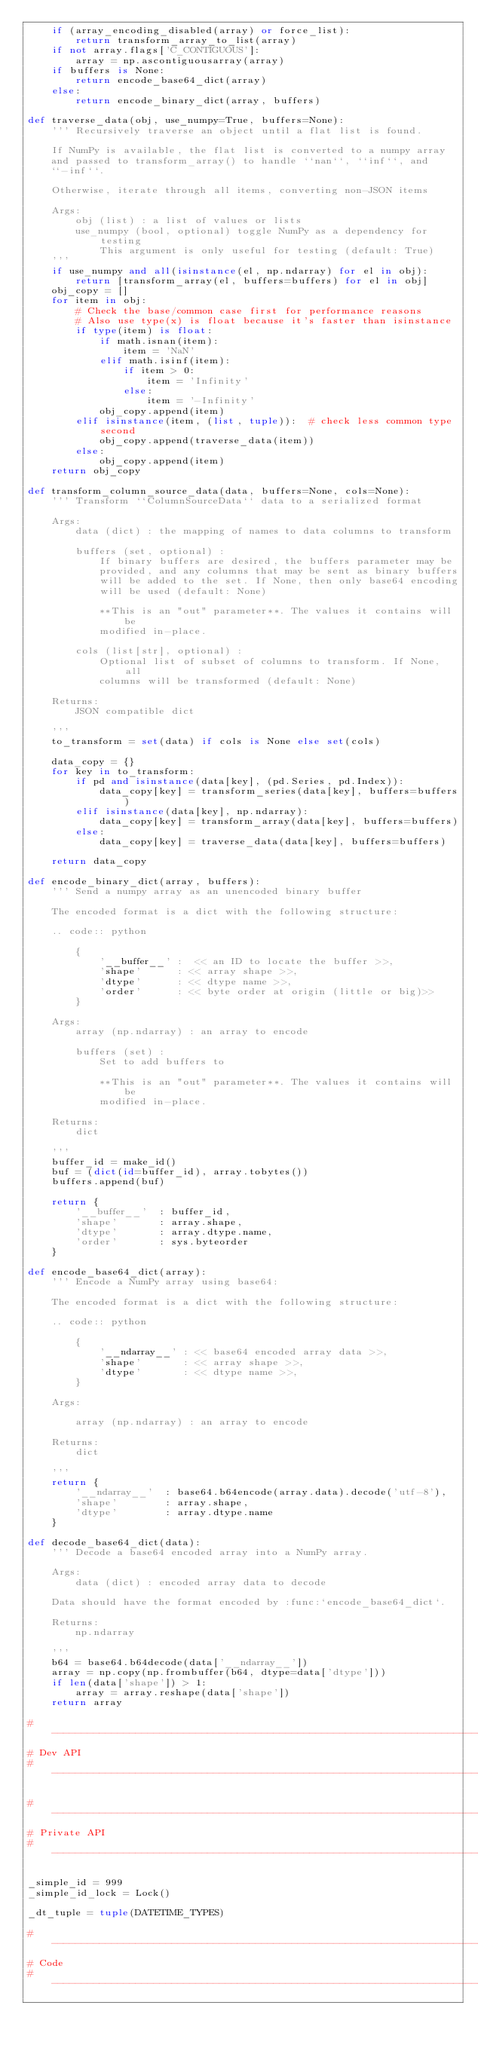Convert code to text. <code><loc_0><loc_0><loc_500><loc_500><_Python_>    if (array_encoding_disabled(array) or force_list):
        return transform_array_to_list(array)
    if not array.flags['C_CONTIGUOUS']:
        array = np.ascontiguousarray(array)
    if buffers is None:
        return encode_base64_dict(array)
    else:
        return encode_binary_dict(array, buffers)

def traverse_data(obj, use_numpy=True, buffers=None):
    ''' Recursively traverse an object until a flat list is found.

    If NumPy is available, the flat list is converted to a numpy array
    and passed to transform_array() to handle ``nan``, ``inf``, and
    ``-inf``.

    Otherwise, iterate through all items, converting non-JSON items

    Args:
        obj (list) : a list of values or lists
        use_numpy (bool, optional) toggle NumPy as a dependency for testing
            This argument is only useful for testing (default: True)
    '''
    if use_numpy and all(isinstance(el, np.ndarray) for el in obj):
        return [transform_array(el, buffers=buffers) for el in obj]
    obj_copy = []
    for item in obj:
        # Check the base/common case first for performance reasons
        # Also use type(x) is float because it's faster than isinstance
        if type(item) is float:
            if math.isnan(item):
                item = 'NaN'
            elif math.isinf(item):
                if item > 0:
                    item = 'Infinity'
                else:
                    item = '-Infinity'
            obj_copy.append(item)
        elif isinstance(item, (list, tuple)):  # check less common type second
            obj_copy.append(traverse_data(item))
        else:
            obj_copy.append(item)
    return obj_copy

def transform_column_source_data(data, buffers=None, cols=None):
    ''' Transform ``ColumnSourceData`` data to a serialized format

    Args:
        data (dict) : the mapping of names to data columns to transform

        buffers (set, optional) :
            If binary buffers are desired, the buffers parameter may be
            provided, and any columns that may be sent as binary buffers
            will be added to the set. If None, then only base64 encoding
            will be used (default: None)

            **This is an "out" parameter**. The values it contains will be
            modified in-place.

        cols (list[str], optional) :
            Optional list of subset of columns to transform. If None, all
            columns will be transformed (default: None)

    Returns:
        JSON compatible dict

    '''
    to_transform = set(data) if cols is None else set(cols)

    data_copy = {}
    for key in to_transform:
        if pd and isinstance(data[key], (pd.Series, pd.Index)):
            data_copy[key] = transform_series(data[key], buffers=buffers)
        elif isinstance(data[key], np.ndarray):
            data_copy[key] = transform_array(data[key], buffers=buffers)
        else:
            data_copy[key] = traverse_data(data[key], buffers=buffers)

    return data_copy

def encode_binary_dict(array, buffers):
    ''' Send a numpy array as an unencoded binary buffer

    The encoded format is a dict with the following structure:

    .. code:: python

        {
            '__buffer__' :  << an ID to locate the buffer >>,
            'shape'      : << array shape >>,
            'dtype'      : << dtype name >>,
            'order'      : << byte order at origin (little or big)>>
        }

    Args:
        array (np.ndarray) : an array to encode

        buffers (set) :
            Set to add buffers to

            **This is an "out" parameter**. The values it contains will be
            modified in-place.

    Returns:
        dict

    '''
    buffer_id = make_id()
    buf = (dict(id=buffer_id), array.tobytes())
    buffers.append(buf)

    return {
        '__buffer__'  : buffer_id,
        'shape'       : array.shape,
        'dtype'       : array.dtype.name,
        'order'       : sys.byteorder
    }

def encode_base64_dict(array):
    ''' Encode a NumPy array using base64:

    The encoded format is a dict with the following structure:

    .. code:: python

        {
            '__ndarray__' : << base64 encoded array data >>,
            'shape'       : << array shape >>,
            'dtype'       : << dtype name >>,
        }

    Args:

        array (np.ndarray) : an array to encode

    Returns:
        dict

    '''
    return {
        '__ndarray__'  : base64.b64encode(array.data).decode('utf-8'),
        'shape'        : array.shape,
        'dtype'        : array.dtype.name
    }

def decode_base64_dict(data):
    ''' Decode a base64 encoded array into a NumPy array.

    Args:
        data (dict) : encoded array data to decode

    Data should have the format encoded by :func:`encode_base64_dict`.

    Returns:
        np.ndarray

    '''
    b64 = base64.b64decode(data['__ndarray__'])
    array = np.copy(np.frombuffer(b64, dtype=data['dtype']))
    if len(data['shape']) > 1:
        array = array.reshape(data['shape'])
    return array

#-----------------------------------------------------------------------------
# Dev API
#-----------------------------------------------------------------------------

#-----------------------------------------------------------------------------
# Private API
#-----------------------------------------------------------------------------

_simple_id = 999
_simple_id_lock = Lock()

_dt_tuple = tuple(DATETIME_TYPES)

#-----------------------------------------------------------------------------
# Code
#-----------------------------------------------------------------------------
</code> 